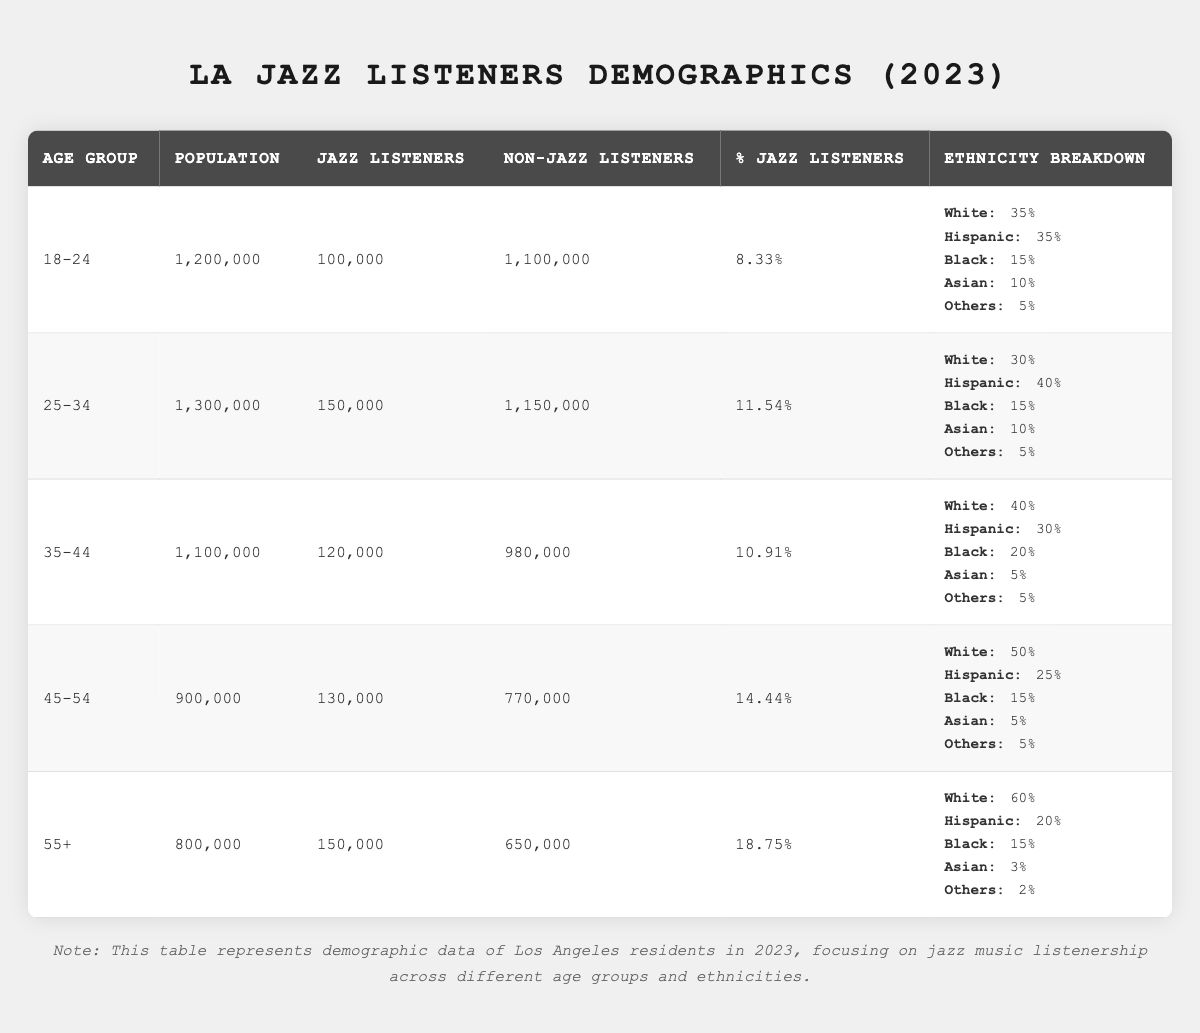What is the total population of jazz listeners in the 18-24 age group? The table shows that in the 18-24 age group, the number of jazz listeners is listed as 100,000. This is the specific value extracted from the table.
Answer: 100,000 What percentage of the 45-54 age group listens to jazz? The percentage of jazz listeners in the 45-54 age group is indicated in the table as 14.44%. This is a direct retrieval from the relevant row.
Answer: 14.44% Which age group has the highest number of jazz listeners? By comparing the jazz listeners across all age groups, the 55+ age group has the highest number of jazz listeners at 150,000. This is determined by examining the respective values in the "Jazz Listeners" column.
Answer: 55+ Is the percentage of jazz listeners higher in the 35-44 age group than in the 25-34 age group? The 35-44 age group has a percentage of 10.91%, while the 25-34 age group has 11.54%. Since 10.91 is less than 11.54, the answer is no.
Answer: No What is the total population for all age groups combined? To find the total population, add the populations of all age groups: 1,200,000 + 1,300,000 + 1,100,000 + 900,000 + 800,000 = 5,300,000. This involves summing the population values across all rows.
Answer: 5,300,000 What is the average percentage of jazz listeners across all age groups? To find the average percentage, add the percentages for all age groups: (8.33 + 11.54 + 10.91 + 14.44 + 18.75) / 5 = 12.194. This uses the arithmetic mean calculation.
Answer: 12.194 How many non-jazz listeners are there in the 25-34 age group compared to the 55+ age group? The non-jazz listeners in the 25-34 age group are 1,150,000, while in the 55+ age group, there are 650,000. When comparing the two, 1,150,000 is greater than 650,000. The answer is based on direct values from the table.
Answer: 1,150,000 is greater Are there more jazz listeners among the 55+ age group than the 18-24 age group? The 55+ age group has 150,000 jazz listeners and the 18-24 age group has 100,000. Since 150,000 is greater than 100,000, the answer is yes.
Answer: Yes What is the difference in the number of jazz listeners between the 45-54 and 35-44 age groups? The number of jazz listeners in the 45-54 age group is 130,000 and in the 35-44 age group is 120,000. The difference is calculated as 130,000 - 120,000 = 10,000.
Answer: 10,000 